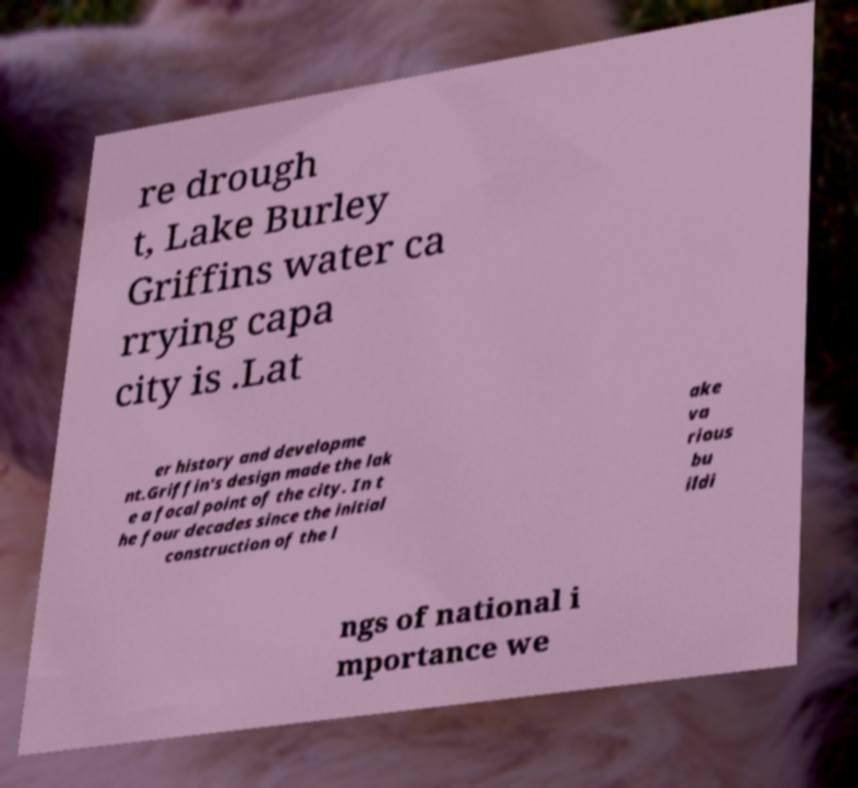Can you read and provide the text displayed in the image?This photo seems to have some interesting text. Can you extract and type it out for me? re drough t, Lake Burley Griffins water ca rrying capa city is .Lat er history and developme nt.Griffin's design made the lak e a focal point of the city. In t he four decades since the initial construction of the l ake va rious bu ildi ngs of national i mportance we 